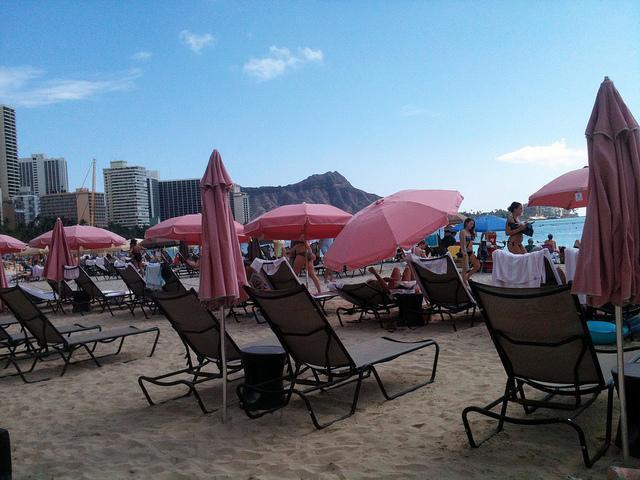How many umbrellas are there?
Give a very brief answer. 4. How many chairs are visible?
Give a very brief answer. 5. How many brown cats are there?
Give a very brief answer. 0. 